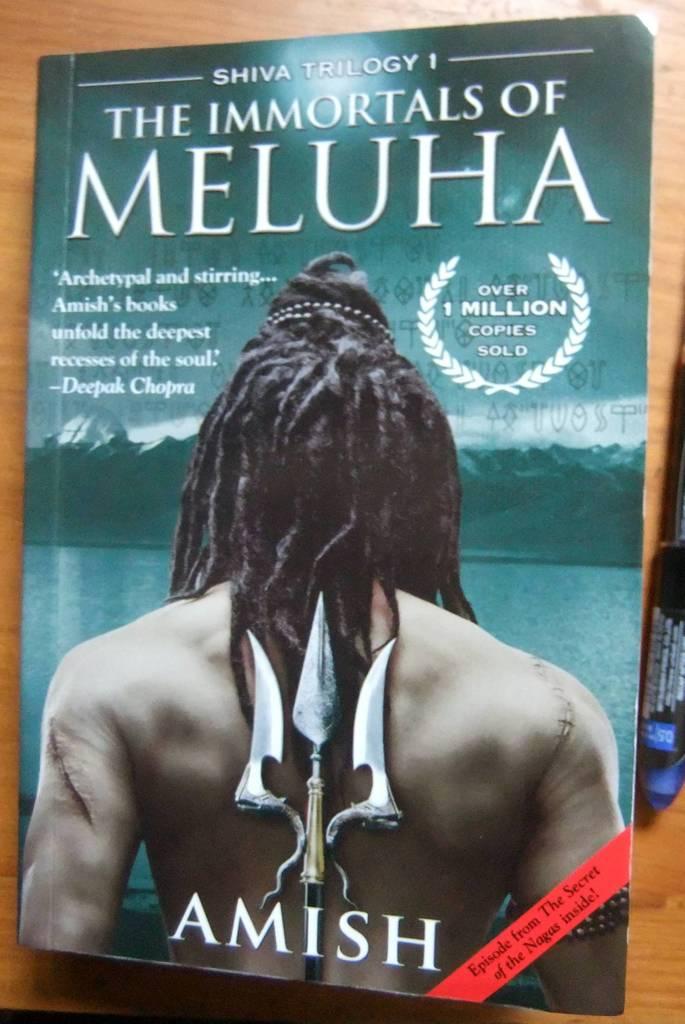What word is written across the bottom of the book?
Make the answer very short. Amish. 